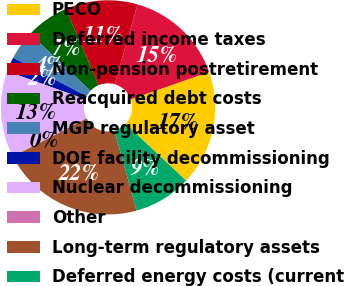Convert chart. <chart><loc_0><loc_0><loc_500><loc_500><pie_chart><fcel>PECO<fcel>Deferred income taxes<fcel>Non-pension postretirement<fcel>Reacquired debt costs<fcel>MGP regulatory asset<fcel>DOE facility decommissioning<fcel>Nuclear decommissioning<fcel>Other<fcel>Long-term regulatory assets<fcel>Deferred energy costs (current<nl><fcel>17.36%<fcel>15.2%<fcel>10.87%<fcel>6.54%<fcel>4.37%<fcel>2.2%<fcel>13.03%<fcel>0.04%<fcel>21.69%<fcel>8.7%<nl></chart> 